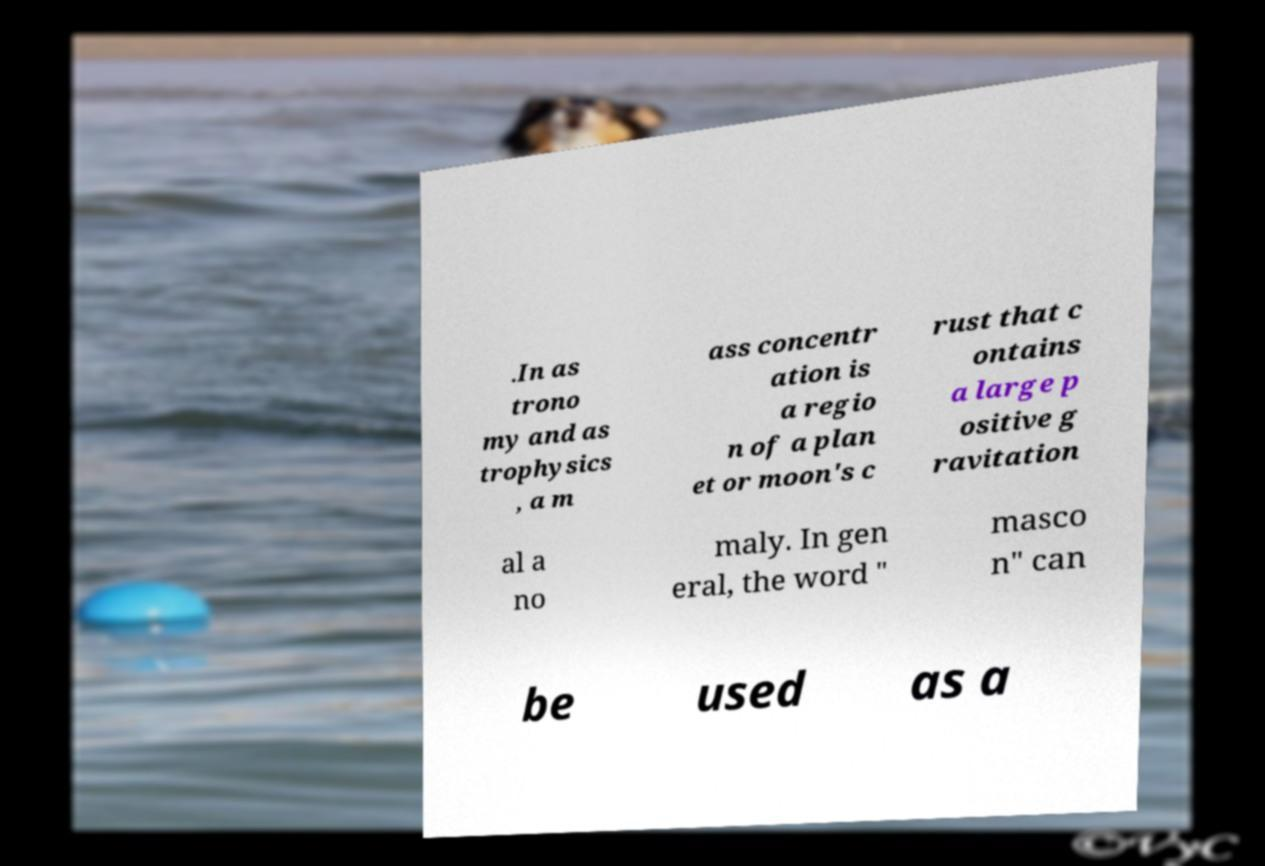Could you extract and type out the text from this image? .In as trono my and as trophysics , a m ass concentr ation is a regio n of a plan et or moon's c rust that c ontains a large p ositive g ravitation al a no maly. In gen eral, the word " masco n" can be used as a 